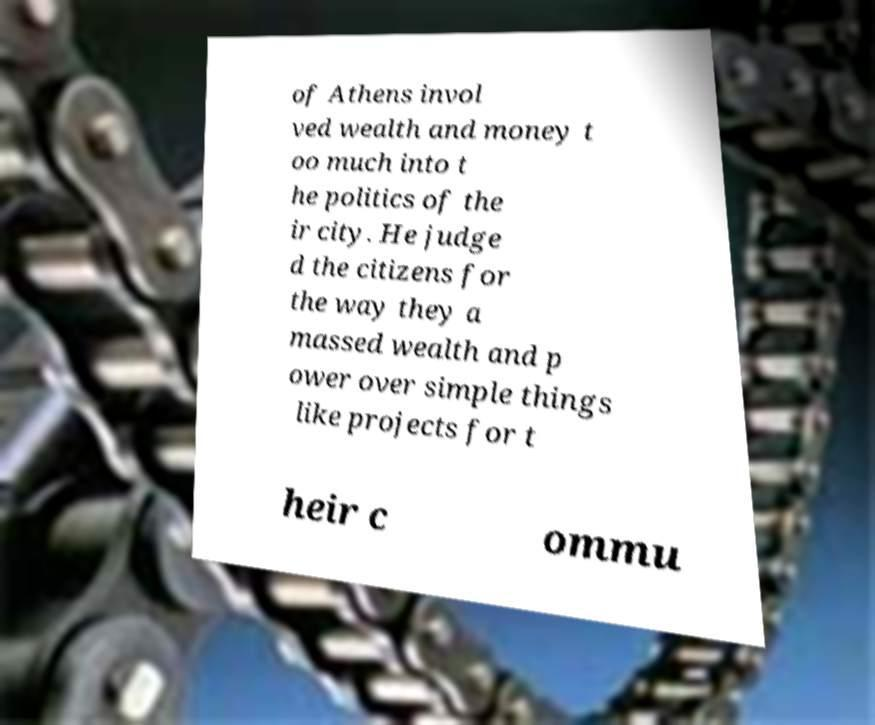Could you assist in decoding the text presented in this image and type it out clearly? of Athens invol ved wealth and money t oo much into t he politics of the ir city. He judge d the citizens for the way they a massed wealth and p ower over simple things like projects for t heir c ommu 